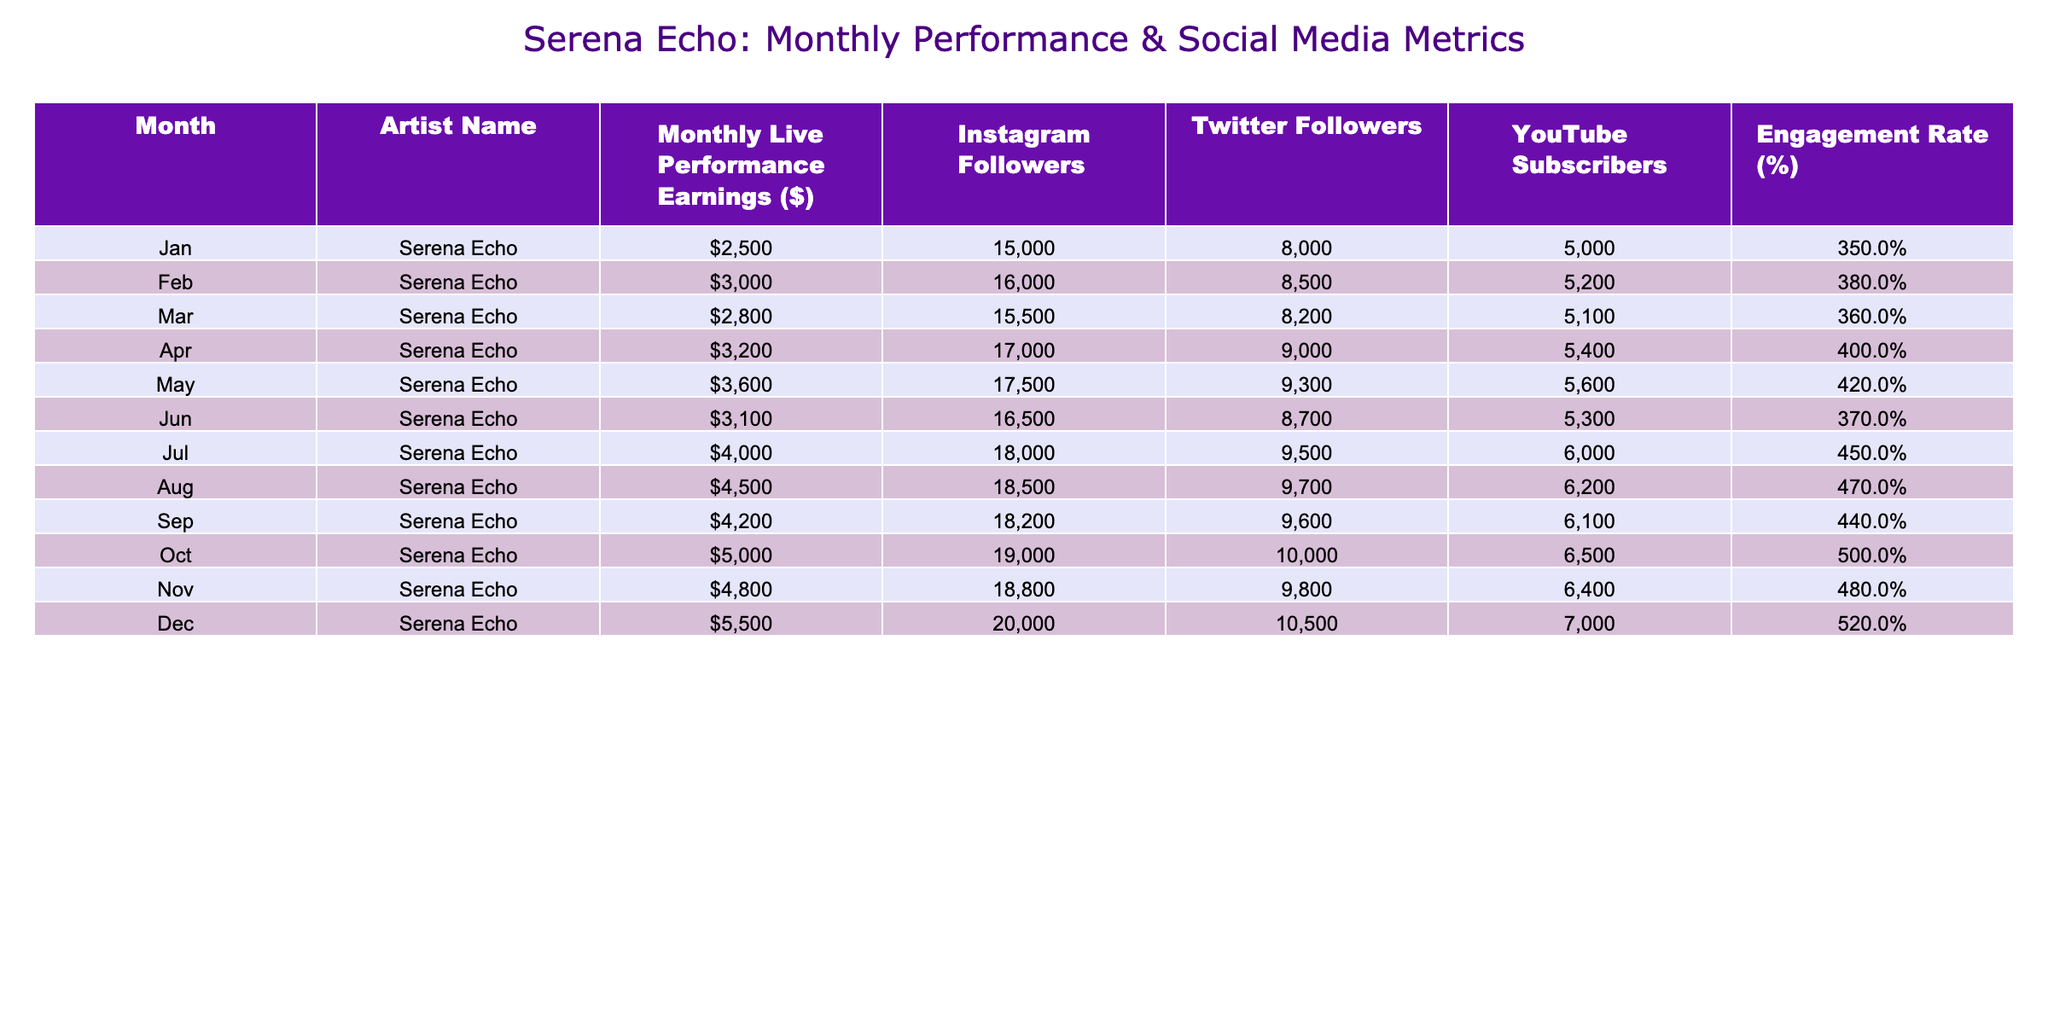What were Serena Echo's highest monthly live performance earnings? By examining the "Monthly Live Performance Earnings ($)" column, we find that the highest value is 5500, which occurs in December.
Answer: 5500 What was the engagement rate in October? The engagement rate for October can be found in the "Engagement Rate (%)" column, where it shows a value of 5.0.
Answer: 5.0 What is the average monthly live performance earnings over the year? To find the average, we first sum all the monthly earnings: 2500 + 3000 + 2800 + 3200 + 3600 + 3100 + 4000 + 4500 + 4200 + 5000 + 4800 + 5500 = 42800. We then divide by the number of months (12), giving an average of 42800/12 ≈ 3566.67.
Answer: 3566.67 Was there an increase in Instagram followers from January to December? Comparing the "Instagram Followers" in January (15000) and December (20000), we see that there was an increase of 5000 followers over the year.
Answer: Yes Which month had the lowest engagement rate and what was it? Looking through the "Engagement Rate (%)" column, the lowest rate is 3.5 in January, which we identify by reviewing all the percentages listed.
Answer: 3.5 What was the difference in earnings between July and September? The earnings for July are 4000 and for September are 4200. We calculate the difference: 4200 - 4000 = 200.
Answer: 200 Did Serena Echo have more Twitter followers in April than in February? In April, Twitter followers were at 9000, while in February they were at 8500. Since 9000 is greater than 8500, the answer is yes.
Answer: Yes What was the total number of YouTube subscribers by the end of the year? The final month, December, shows YouTube subscribers at 7000. Therefore, the total number of subscribers as of December is 7000.
Answer: 7000 In which month did Serena Echo see the greatest percentage increase in earnings compared to the previous month? To determine this, we compare each month's earnings to the preceding month. The increase from November (4800) to December (5500) is the largest percentage change: (5500 - 4800) / 4800 * 100 = 14.58%. Therefore, December had the greatest percentage increase.
Answer: December 